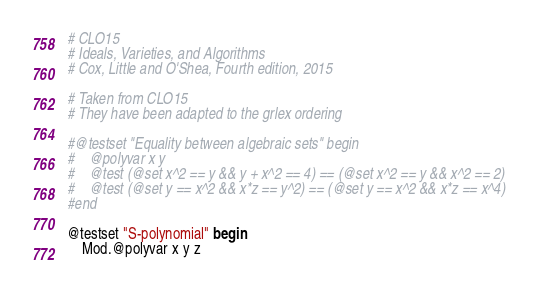Convert code to text. <code><loc_0><loc_0><loc_500><loc_500><_Julia_># CLO15
# Ideals, Varieties, and Algorithms
# Cox, Little and O'Shea, Fourth edition, 2015

# Taken from CLO15
# They have been adapted to the grlex ordering

#@testset "Equality between algebraic sets" begin
#    @polyvar x y
#    @test (@set x^2 == y && y + x^2 == 4) == (@set x^2 == y && x^2 == 2)
#    @test (@set y == x^2 && x*z == y^2) == (@set y == x^2 && x*z == x^4)
#end

@testset "S-polynomial" begin
    Mod.@polyvar x y z</code> 